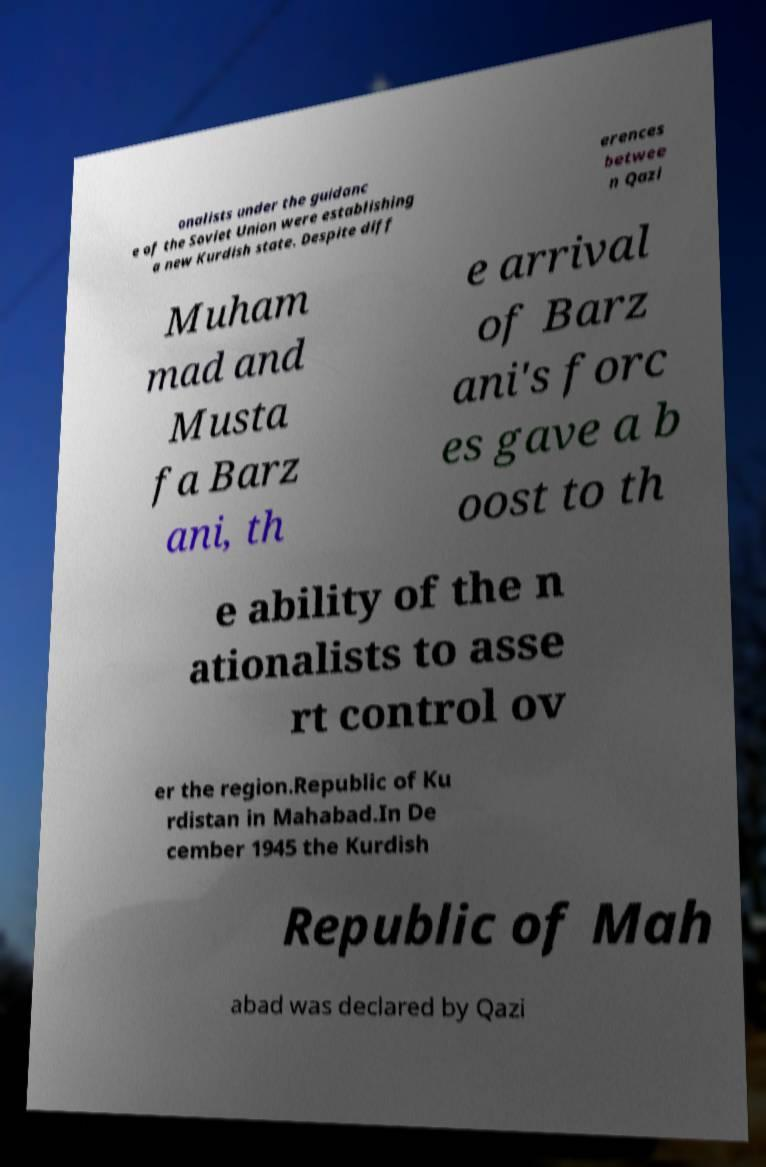For documentation purposes, I need the text within this image transcribed. Could you provide that? onalists under the guidanc e of the Soviet Union were establishing a new Kurdish state. Despite diff erences betwee n Qazi Muham mad and Musta fa Barz ani, th e arrival of Barz ani's forc es gave a b oost to th e ability of the n ationalists to asse rt control ov er the region.Republic of Ku rdistan in Mahabad.In De cember 1945 the Kurdish Republic of Mah abad was declared by Qazi 